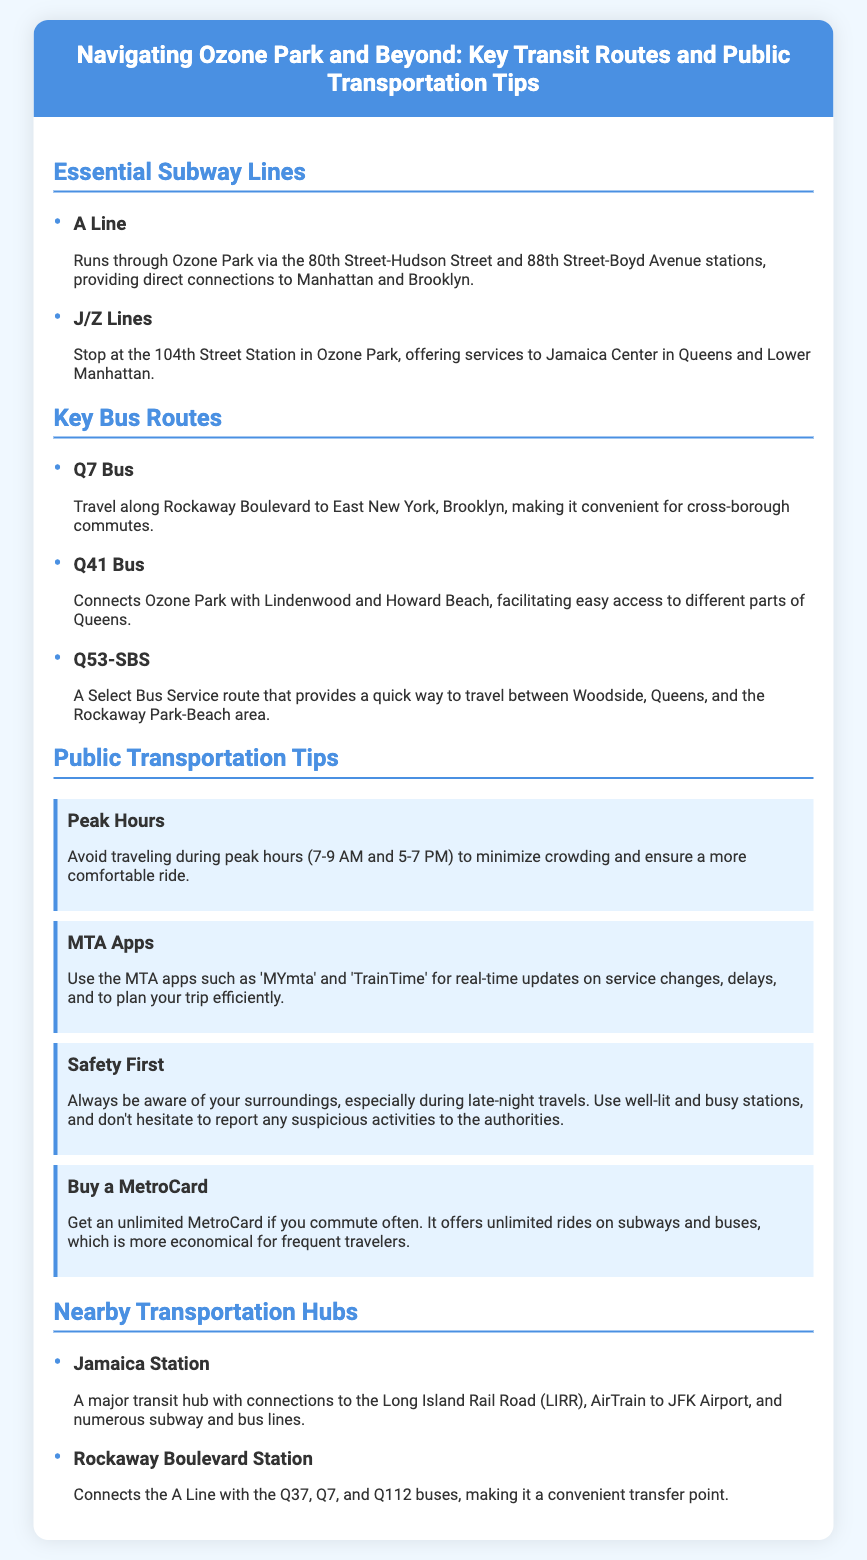What subway line runs through Ozone Park? The document states that the A Line runs through Ozone Park via specific stations.
Answer: A Line Which bus connects Ozone Park with Lindenwood? The Q41 Bus is specifically mentioned as connecting Ozone Park with Lindenwood.
Answer: Q41 Bus What is suggested to avoid during peak hours? The tip recommends avoiding traveling during peak hours, specifically from 7-9 AM and 5-7 PM.
Answer: Peak hours What should you use for real-time transit updates? The document mentions using MTA apps such as 'MYmta' and 'TrainTime' for updates.
Answer: MTA apps Which transportation hub is a major transit hub with connections to the Long Island Rail Road? Jamaica Station is identified as a major transit hub in the document.
Answer: Jamaica Station What type of MetroCard is recommended for frequent travelers? The document suggests getting an unlimited MetroCard for those who commute often.
Answer: Unlimited MetroCard Which subway lines stop at the 104th Street Station? The J/Z Lines are specified to stop at the 104th Street Station in Ozone Park.
Answer: J/Z Lines What is a recommended tip for safety during travels? The document advises being aware of surroundings, especially during late-night travels.
Answer: Be aware of surroundings 